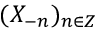Convert formula to latex. <formula><loc_0><loc_0><loc_500><loc_500>( X _ { - n } ) _ { n \in Z }</formula> 